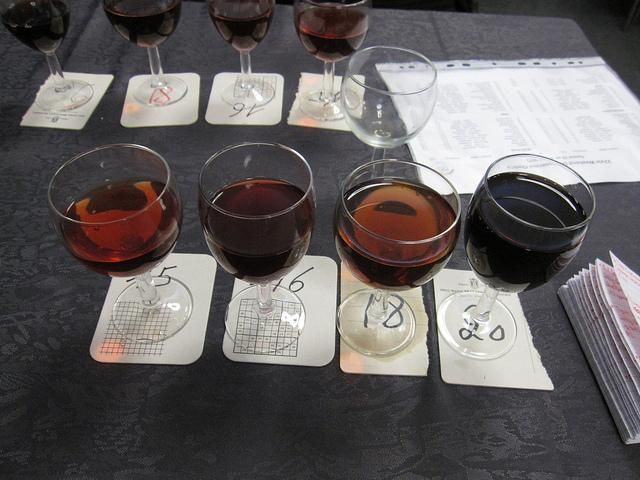What activity is the person taking this pic taking part in here? Please explain your reasoning. tasting. A wine tasting is being conducted. 